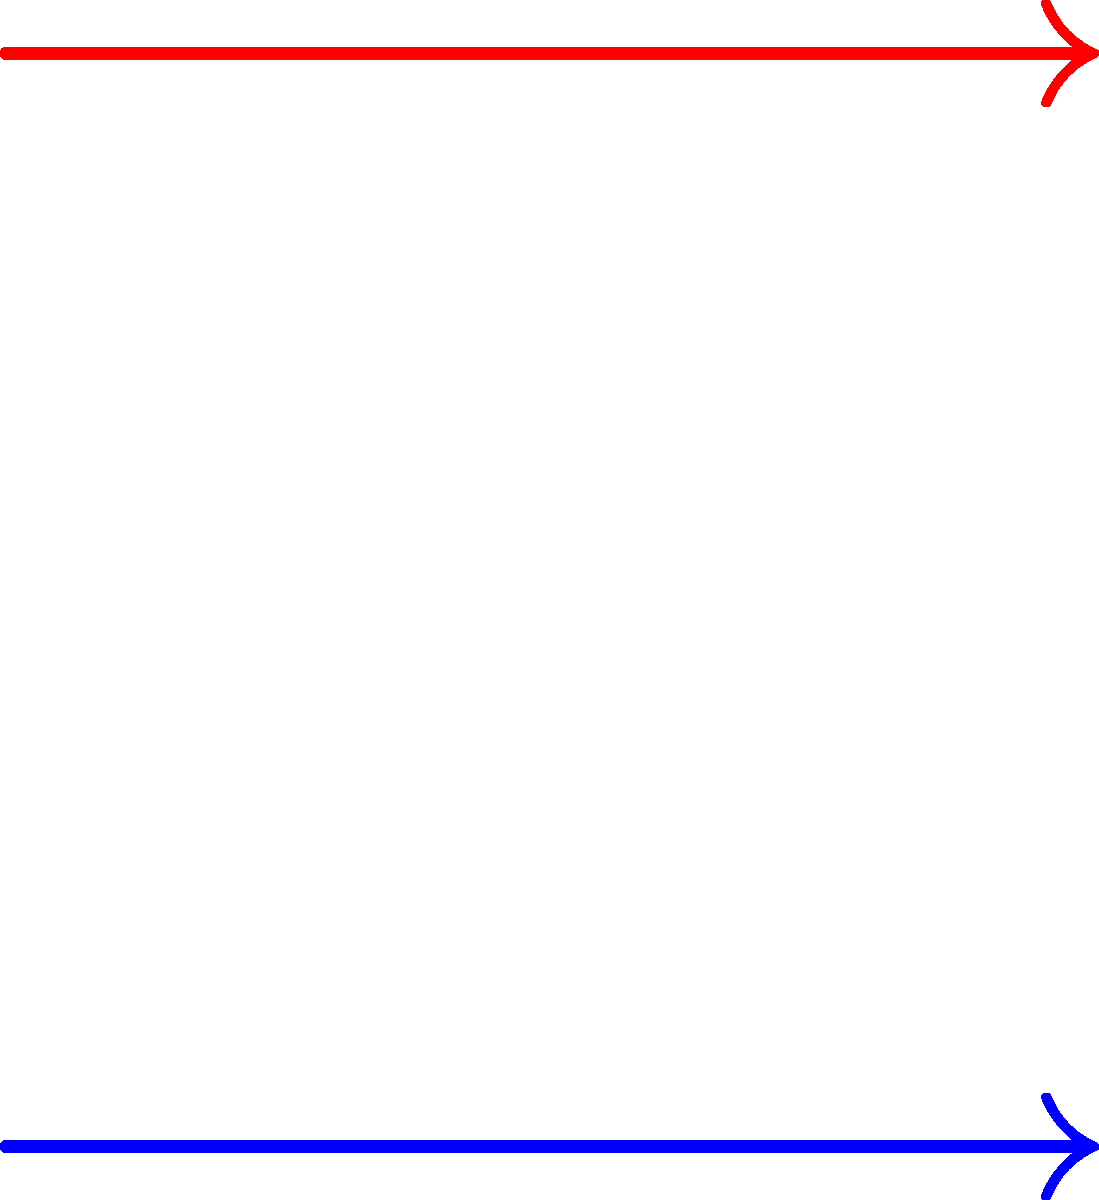In the diagram above, two parallel current-carrying wires are shown with their respective magnetic field lines. Given that the current in the lower wire ($I_1$) is flowing out of the page and the current in the upper wire ($I_2$) is flowing into the page, what can be concluded about the magnetic force between these two wires? Justify your answer using the right-hand rule and the concept of magnetic field superposition. Let's approach this step-by-step, shall we? Try to keep up.

1) First, recall the right-hand rule for magnetic fields around current-carrying wires. For $I_1$ (out of the page), the magnetic field lines circulate counterclockwise. For $I_2$ (into the page), they circulate clockwise.

2) Now, let's consider the magnetic field created by $I_1$ at the location of $I_2$. According to our right-hand rule, this field points to the left at $I_2$'s position.

3) Next, we need to determine the force on $I_2$ due to this magnetic field. We use the force equation $\mathbf{F} = I\mathbf{L} \times \mathbf{B}$. The current $I_2$ is into the page, the magnetic field from $I_1$ is to the left, so the cross product gives a force downward.

4) By Newton's third law, $I_1$ must experience an equal and opposite force upward due to the magnetic field of $I_2$.

5) The magnetic field lines in the diagram corroborate this analysis. Notice how the field lines are compressed between the wires, indicating a region of higher field strength, which is consistent with attractive forces between the wires.

6) This result is general: parallel currents in the same direction always attract, while antiparallel currents repel. It's a fundamental principle in electromagnetism, not some hand-wavy approximation.

Therefore, the magnetic force between these two wires is attractive. The wires will be pulled towards each other due to their antiparallel currents.
Answer: Attractive force 